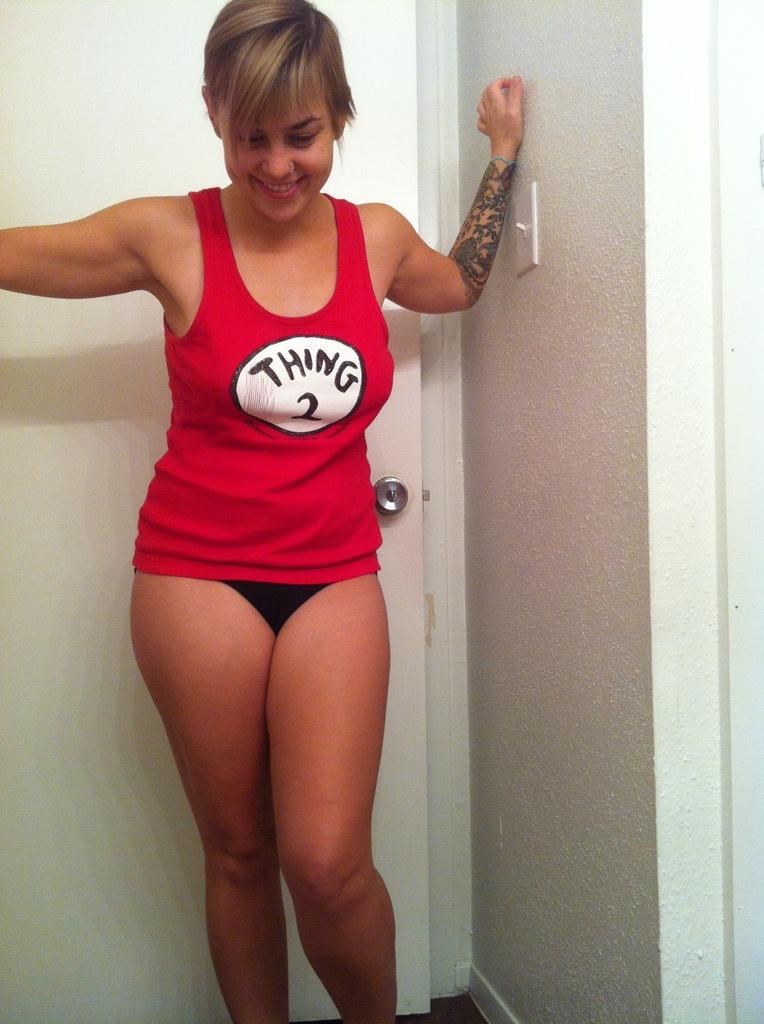What number is on her shirt?
Your answer should be compact. 2. What 2 is it?
Your answer should be very brief. Thing. 